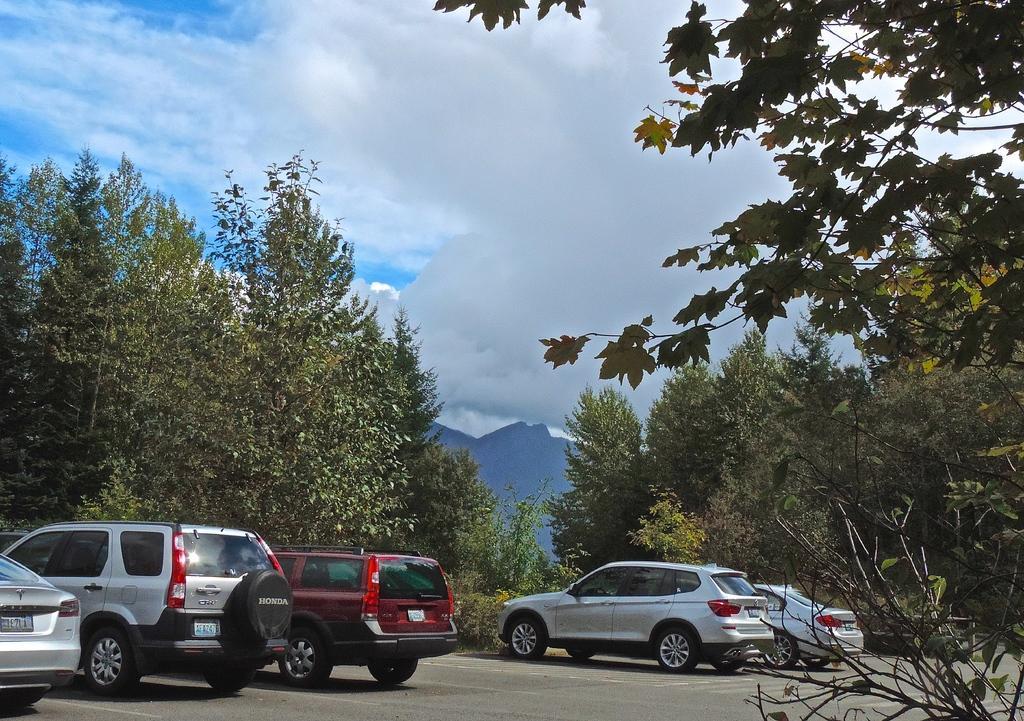Describe this image in one or two sentences. At the bottom there are cars that are parked on the road and there are trees at here. At the top it is the cloudy sky. 